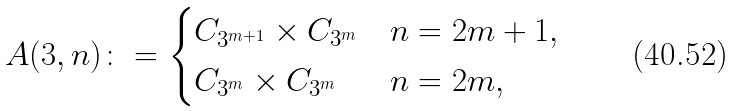<formula> <loc_0><loc_0><loc_500><loc_500>A ( 3 , n ) \colon = \begin{cases} C _ { 3 ^ { m + 1 } } \times C _ { 3 ^ { m } } & n = 2 m + 1 , \\ C _ { 3 ^ { m } } \times C _ { 3 ^ { m } } & n = 2 m , \end{cases}</formula> 